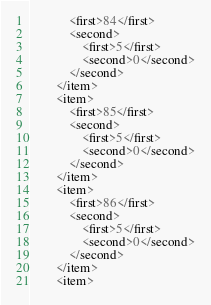Convert code to text. <code><loc_0><loc_0><loc_500><loc_500><_Ada_>			<first>84</first>
			<second>
				<first>5</first>
				<second>0</second>
			</second>
		</item>
		<item>
			<first>85</first>
			<second>
				<first>5</first>
				<second>0</second>
			</second>
		</item>
		<item>
			<first>86</first>
			<second>
				<first>5</first>
				<second>0</second>
			</second>
		</item>
		<item></code> 